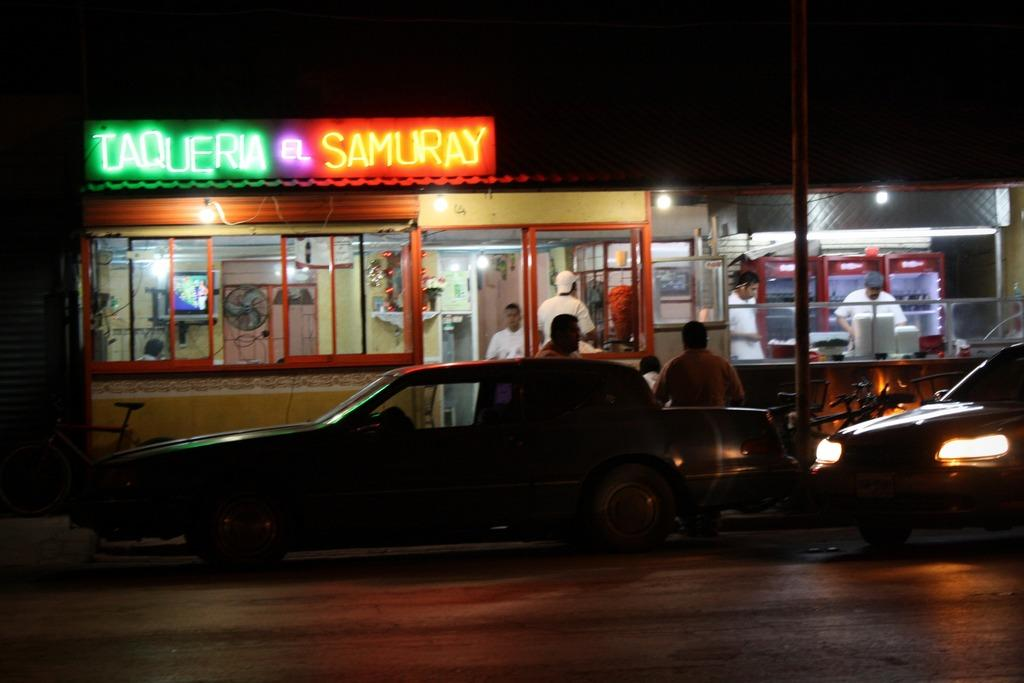What is in the center of the image? There are cars on the road in the center of the image. What can be seen in the background of the image? There are stores in the background of the image. Are there any people visible in the image? Yes, there are people visible in the image. What type of print can be seen on the cars in the image? There is no specific print mentioned on the cars in the image; we can only see that there are cars on the road. 